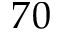Convert formula to latex. <formula><loc_0><loc_0><loc_500><loc_500>7 0</formula> 